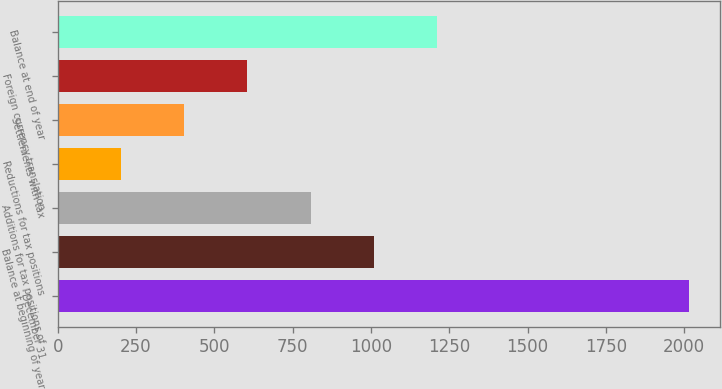<chart> <loc_0><loc_0><loc_500><loc_500><bar_chart><fcel>December 31<fcel>Balance at beginning of year<fcel>Additions for tax positions of<fcel>Reductions for tax positions<fcel>Settlements with tax<fcel>Foreign currency translation<fcel>Balance at end of year<nl><fcel>2015<fcel>1008.5<fcel>807.2<fcel>203.3<fcel>404.6<fcel>605.9<fcel>1209.8<nl></chart> 